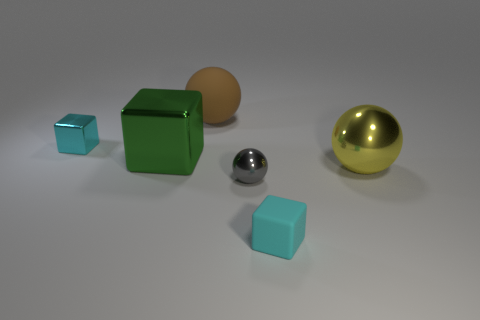How many gray things are either spheres or small shiny objects?
Ensure brevity in your answer.  1. How many other things are the same shape as the large green shiny object?
Give a very brief answer. 2. There is a metallic thing that is both in front of the green metallic cube and on the left side of the rubber block; what shape is it?
Ensure brevity in your answer.  Sphere. There is a gray shiny object; are there any yellow balls in front of it?
Ensure brevity in your answer.  No. What is the size of the other cyan thing that is the same shape as the small cyan rubber object?
Your answer should be very brief. Small. Does the gray metal thing have the same shape as the big brown object?
Provide a succinct answer. Yes. What size is the cyan block that is right of the tiny cyan object that is to the left of the large green metallic object?
Your response must be concise. Small. What color is the other metal thing that is the same shape as the cyan shiny object?
Keep it short and to the point. Green. What number of shiny objects have the same color as the tiny matte cube?
Keep it short and to the point. 1. The green shiny block is what size?
Your response must be concise. Large. 